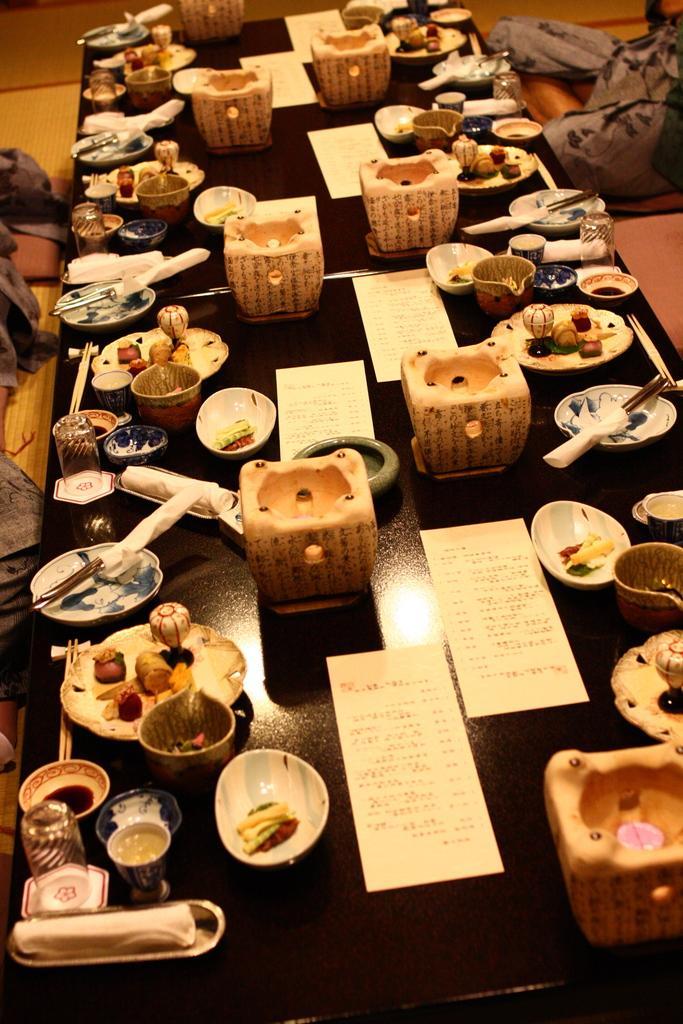Describe this image in one or two sentences. In this picture we can see cards, bowls, plates, jars, chopsticks on a table and in the background we can see some objects. 